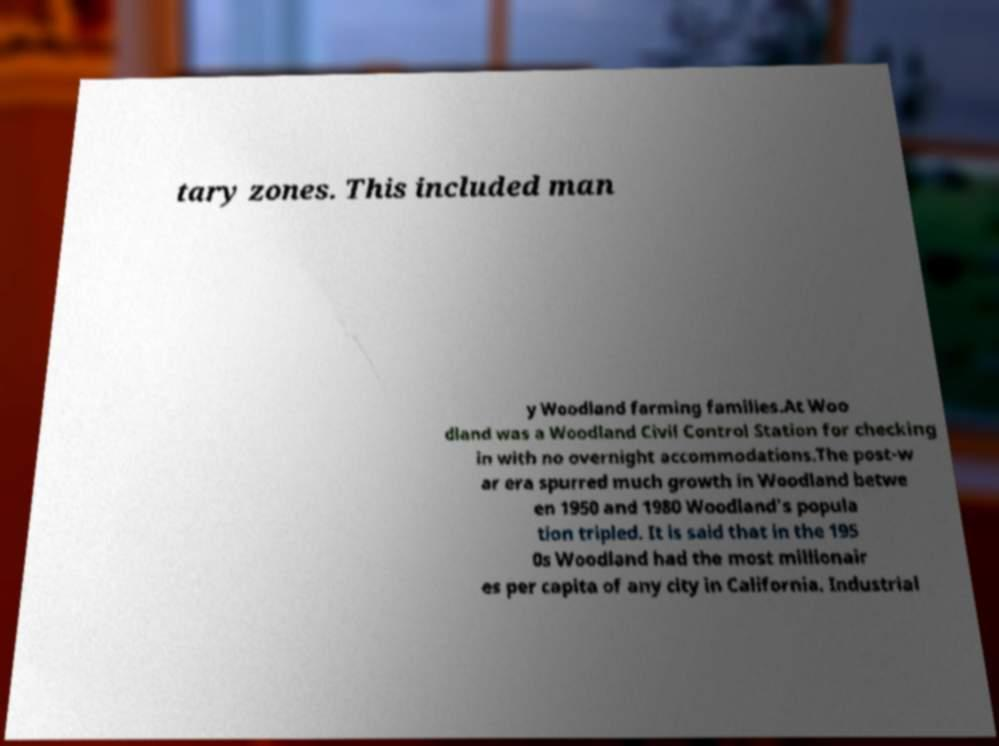Please read and relay the text visible in this image. What does it say? tary zones. This included man y Woodland farming families.At Woo dland was a Woodland Civil Control Station for checking in with no overnight accommodations.The post-w ar era spurred much growth in Woodland betwe en 1950 and 1980 Woodland's popula tion tripled. It is said that in the 195 0s Woodland had the most millionair es per capita of any city in California. Industrial 